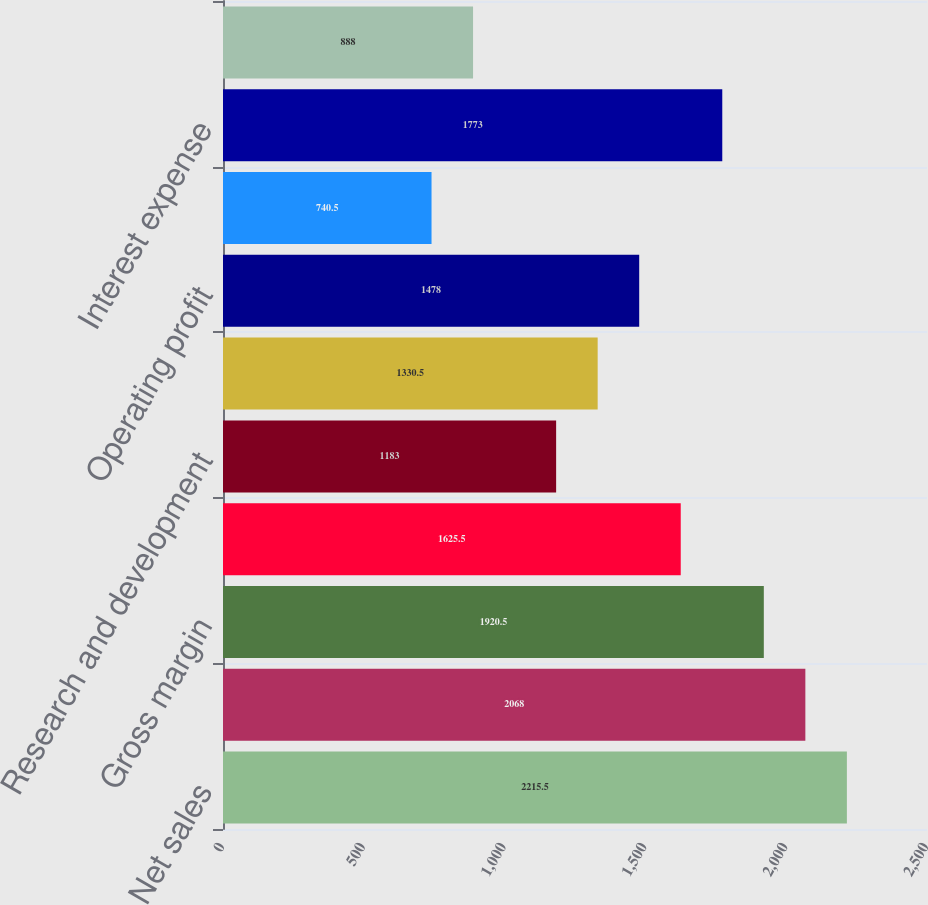<chart> <loc_0><loc_0><loc_500><loc_500><bar_chart><fcel>Net sales<fcel>Cost of sales<fcel>Gross margin<fcel>Selling general and<fcel>Research and development<fcel>Restructuring impairment and<fcel>Operating profit<fcel>Equity in net earnings of<fcel>Interest expense<fcel>Interest income<nl><fcel>2215.5<fcel>2068<fcel>1920.5<fcel>1625.5<fcel>1183<fcel>1330.5<fcel>1478<fcel>740.5<fcel>1773<fcel>888<nl></chart> 